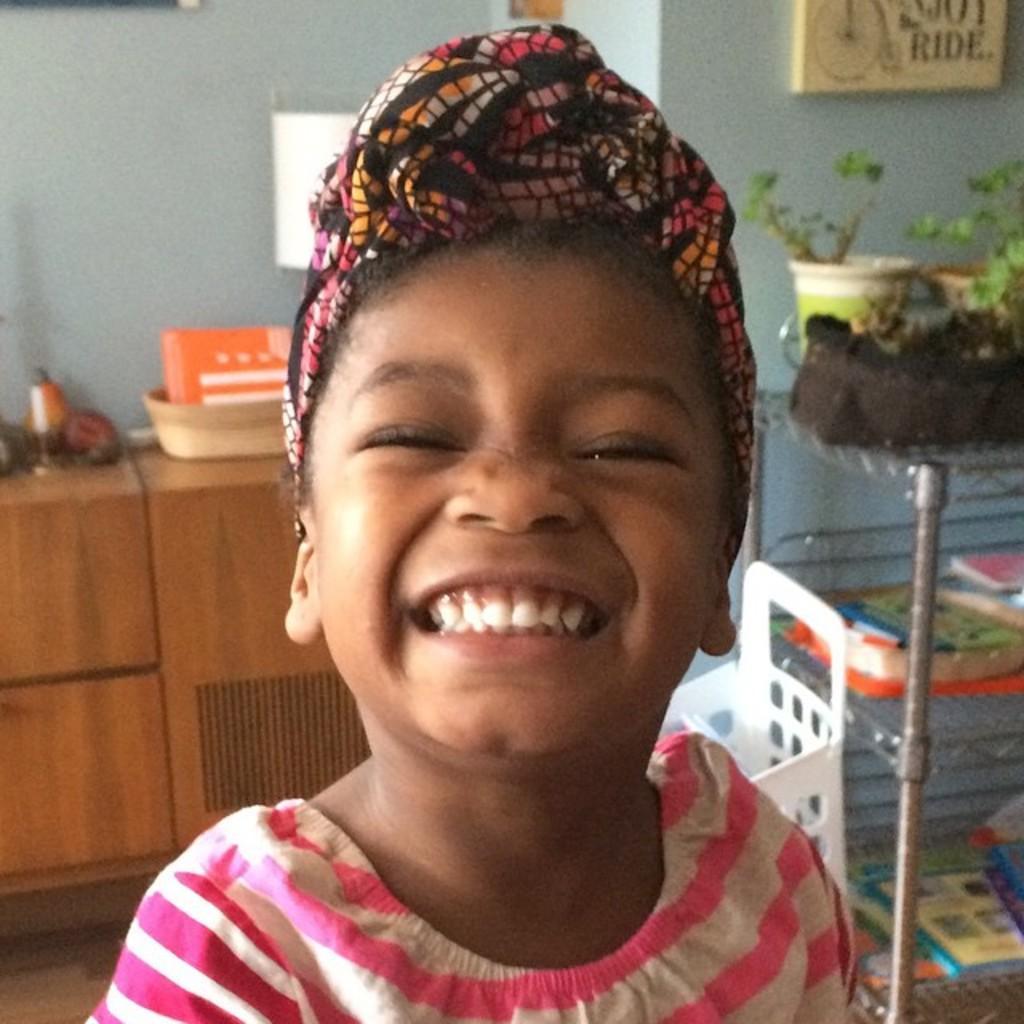Can you describe this image briefly? This is the girl standing and smiling. I can see the flower pots with the plants, books and few other things are placed in the rack. This looks like a basket. At the top of the image, I can see a frame, which is attached to the wall. I can see a tray and few other objects are placed above the cupboard. This looks like a wooden cupboard. 